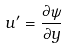<formula> <loc_0><loc_0><loc_500><loc_500>u ^ { \prime } = \frac { \partial \psi } { \partial y }</formula> 